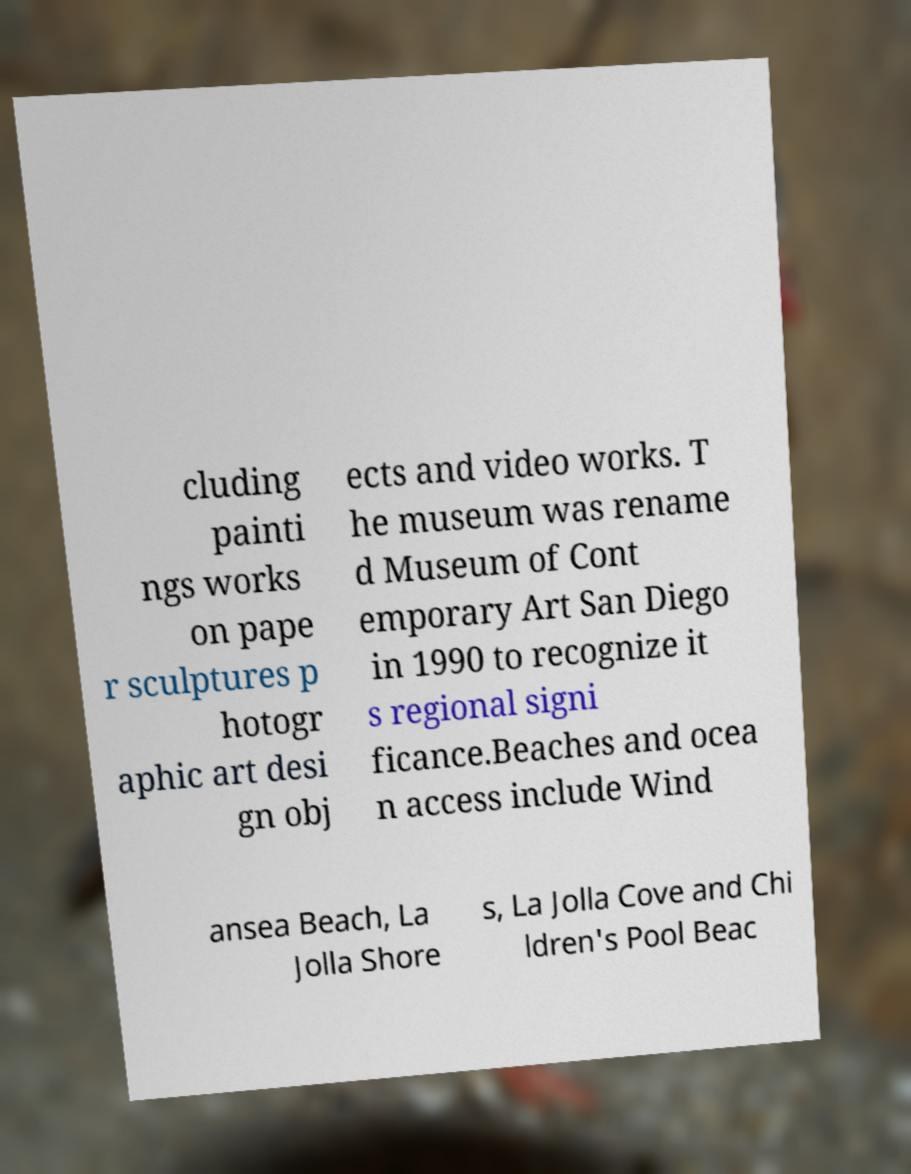Could you assist in decoding the text presented in this image and type it out clearly? cluding painti ngs works on pape r sculptures p hotogr aphic art desi gn obj ects and video works. T he museum was rename d Museum of Cont emporary Art San Diego in 1990 to recognize it s regional signi ficance.Beaches and ocea n access include Wind ansea Beach, La Jolla Shore s, La Jolla Cove and Chi ldren's Pool Beac 